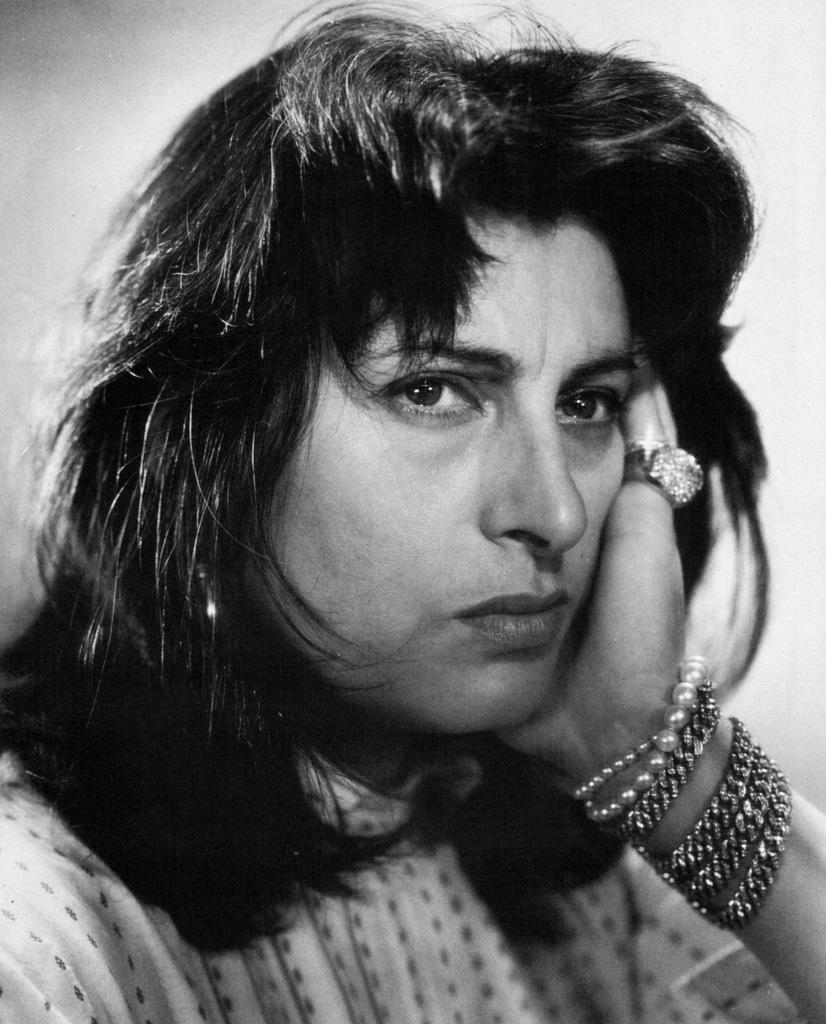Who is present in the image? There is a woman in the image. What can be seen in the background of the image? There is a wall in the image. What type of cart is being used to transport waste in the image? There is no cart or waste present in the image; it only features a woman and a wall. 